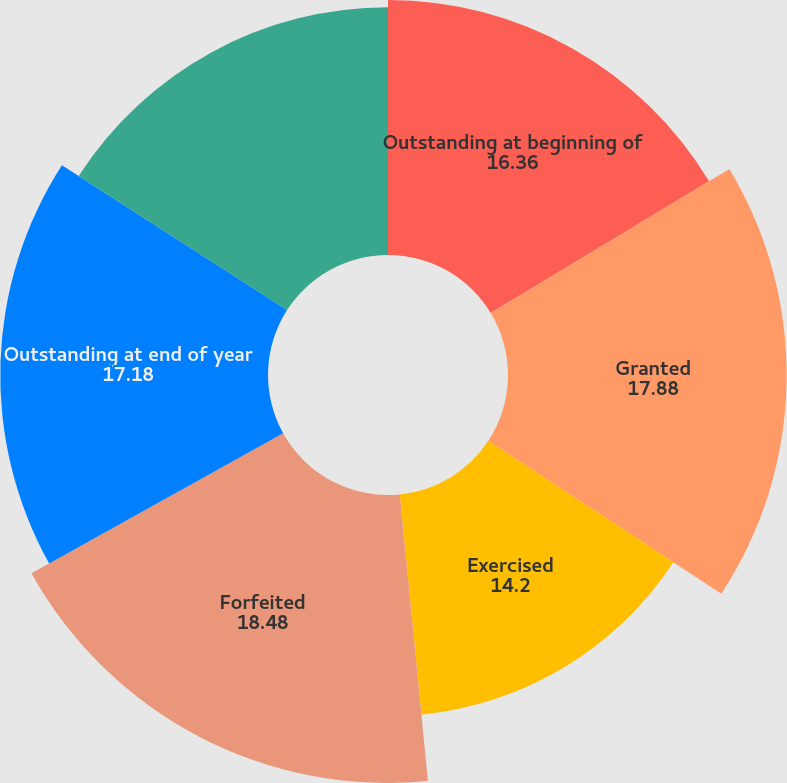Convert chart to OTSL. <chart><loc_0><loc_0><loc_500><loc_500><pie_chart><fcel>Outstanding at beginning of<fcel>Granted<fcel>Exercised<fcel>Forfeited<fcel>Outstanding at end of year<fcel>Exercisable at end of year<nl><fcel>16.36%<fcel>17.88%<fcel>14.2%<fcel>18.48%<fcel>17.18%<fcel>15.9%<nl></chart> 